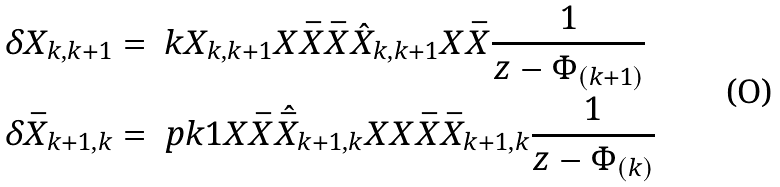<formula> <loc_0><loc_0><loc_500><loc_500>& \delta X _ { k , k + 1 } = \ k X _ { k , k + 1 } X \bar { X } \bar { X } \hat { X } _ { k , k + 1 } X \bar { X } \frac { 1 } { z - \Phi _ { ( k + 1 ) } } \\ & \delta \bar { X } _ { k + 1 , k } = \ p k 1 X \bar { X } \hat { \bar { X } } _ { k + 1 , k } X X \bar { X } \bar { X } _ { k + 1 , k } \frac { 1 } { z - \Phi _ { ( k ) } }</formula> 